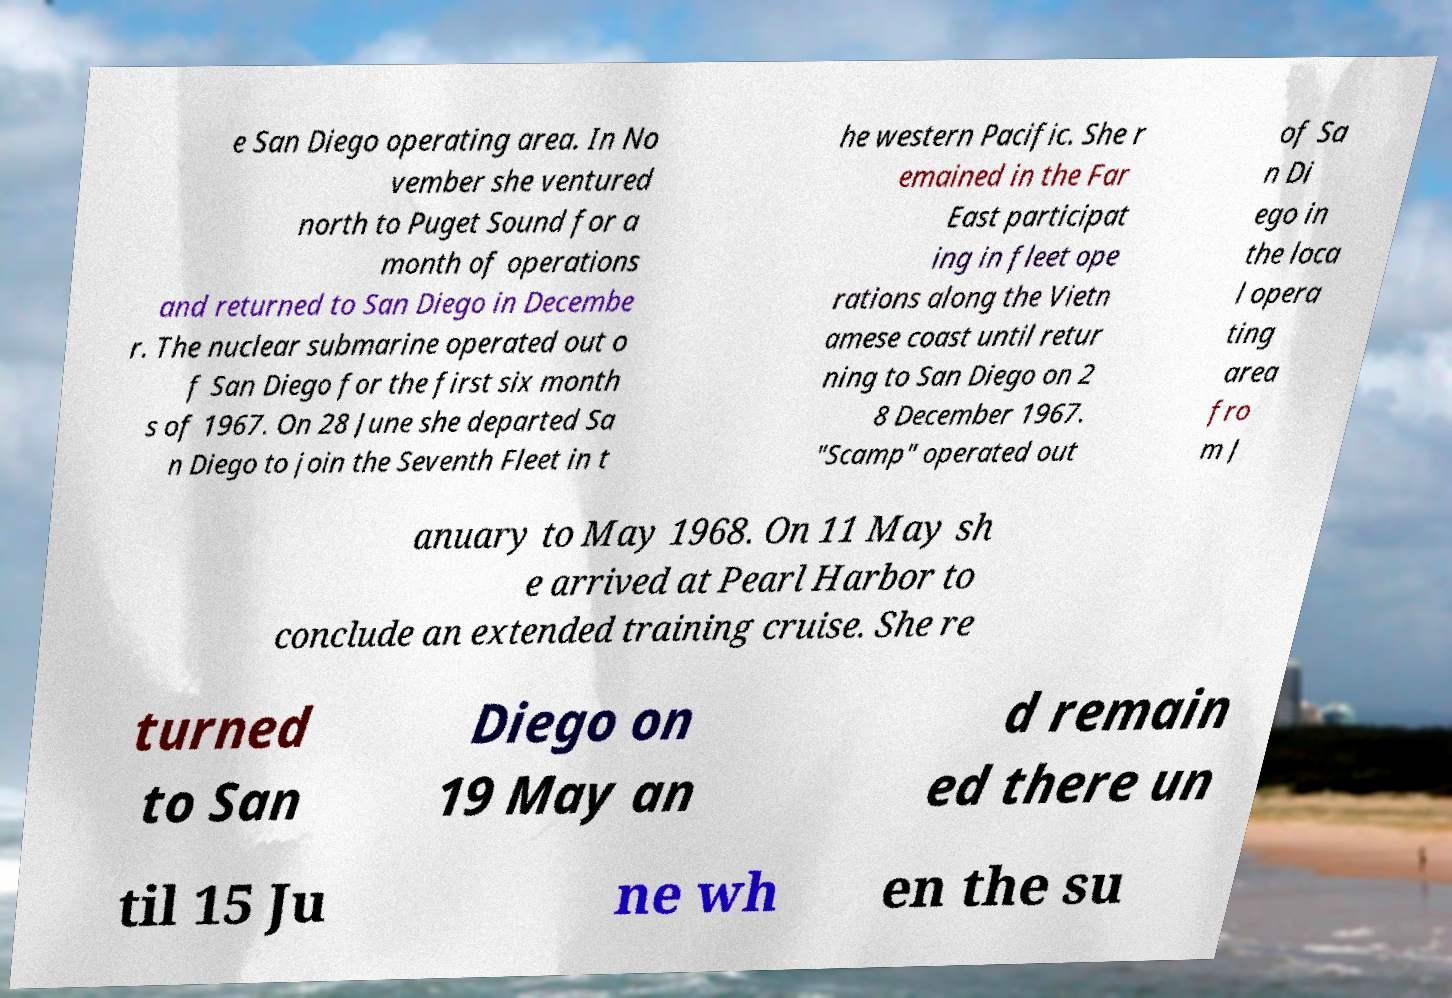What messages or text are displayed in this image? I need them in a readable, typed format. e San Diego operating area. In No vember she ventured north to Puget Sound for a month of operations and returned to San Diego in Decembe r. The nuclear submarine operated out o f San Diego for the first six month s of 1967. On 28 June she departed Sa n Diego to join the Seventh Fleet in t he western Pacific. She r emained in the Far East participat ing in fleet ope rations along the Vietn amese coast until retur ning to San Diego on 2 8 December 1967. "Scamp" operated out of Sa n Di ego in the loca l opera ting area fro m J anuary to May 1968. On 11 May sh e arrived at Pearl Harbor to conclude an extended training cruise. She re turned to San Diego on 19 May an d remain ed there un til 15 Ju ne wh en the su 